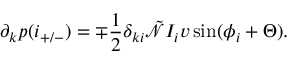<formula> <loc_0><loc_0><loc_500><loc_500>\partial _ { k } p ( i _ { + / - } ) = \mp \frac { 1 } { 2 } \delta _ { k i } \tilde { \mathcal { N } } I _ { i } v \sin ( \phi _ { i } + \Theta ) .</formula> 